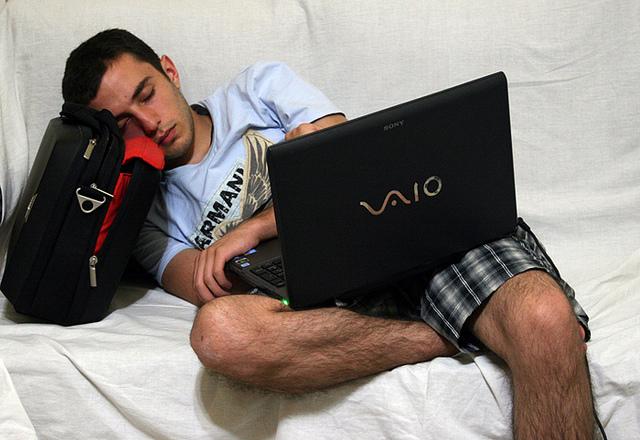Is the man so hairy?
Be succinct. Yes. What is the word on the lid of the laptop?
Answer briefly. Vaio. Did the laptop put the man to sleep?
Give a very brief answer. Yes. 